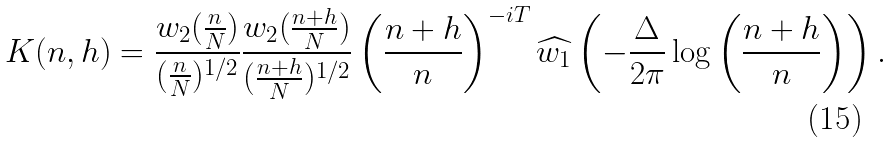<formula> <loc_0><loc_0><loc_500><loc_500>K ( n , h ) = \frac { w _ { 2 } ( \frac { n } { N } ) } { ( \frac { n } { N } ) ^ { 1 / 2 } } \frac { w _ { 2 } ( \frac { n + h } { N } ) } { ( \frac { n + h } { N } ) ^ { 1 / 2 } } \left ( \frac { n + h } { n } \right ) ^ { - i T } \widehat { w _ { 1 } } \left ( - \frac { \Delta } { 2 \pi } \log \left ( \frac { n + h } { n } \right ) \right ) .</formula> 